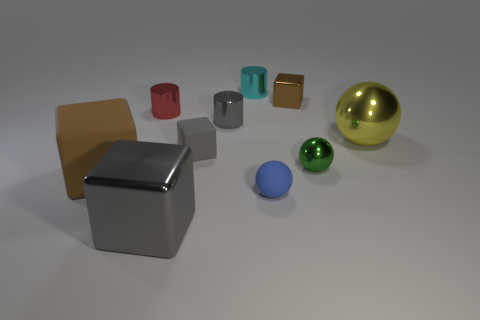How many gray cubes must be subtracted to get 1 gray cubes? 1 Subtract all tiny blue matte balls. How many balls are left? 2 Subtract 1 spheres. How many spheres are left? 2 Subtract all cyan cylinders. How many cylinders are left? 2 Subtract all red cylinders. How many brown blocks are left? 2 Subtract all cylinders. How many objects are left? 7 Subtract all yellow objects. Subtract all blue balls. How many objects are left? 8 Add 7 tiny cyan metal cylinders. How many tiny cyan metal cylinders are left? 8 Add 3 small metal cylinders. How many small metal cylinders exist? 6 Subtract 0 red blocks. How many objects are left? 10 